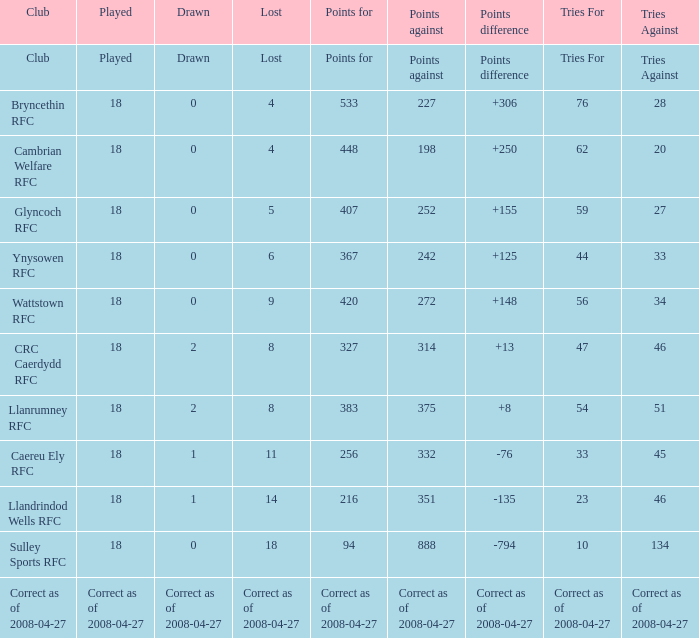If "tries" has a value of 47, what is the value associated with the "lost" item? 8.0. 